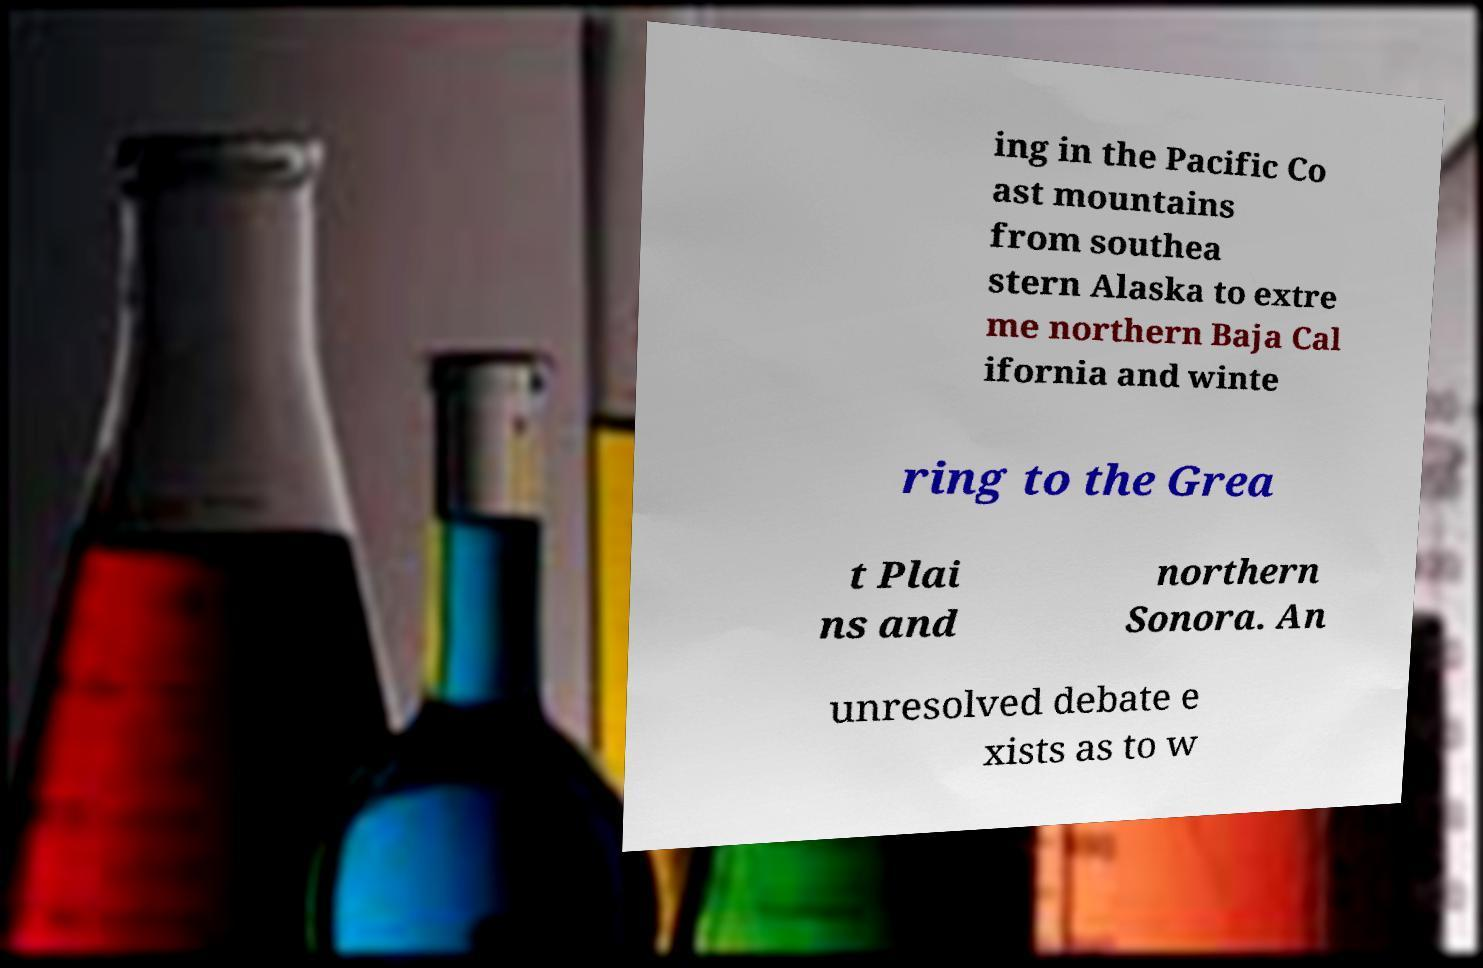What messages or text are displayed in this image? I need them in a readable, typed format. ing in the Pacific Co ast mountains from southea stern Alaska to extre me northern Baja Cal ifornia and winte ring to the Grea t Plai ns and northern Sonora. An unresolved debate e xists as to w 